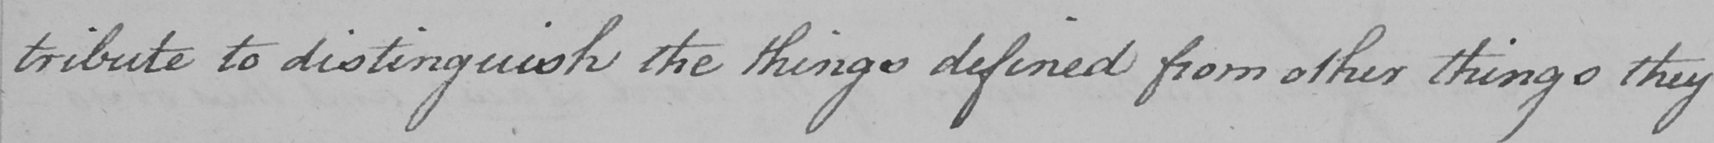What text is written in this handwritten line? tribute to distinguish the things defined from other things they 